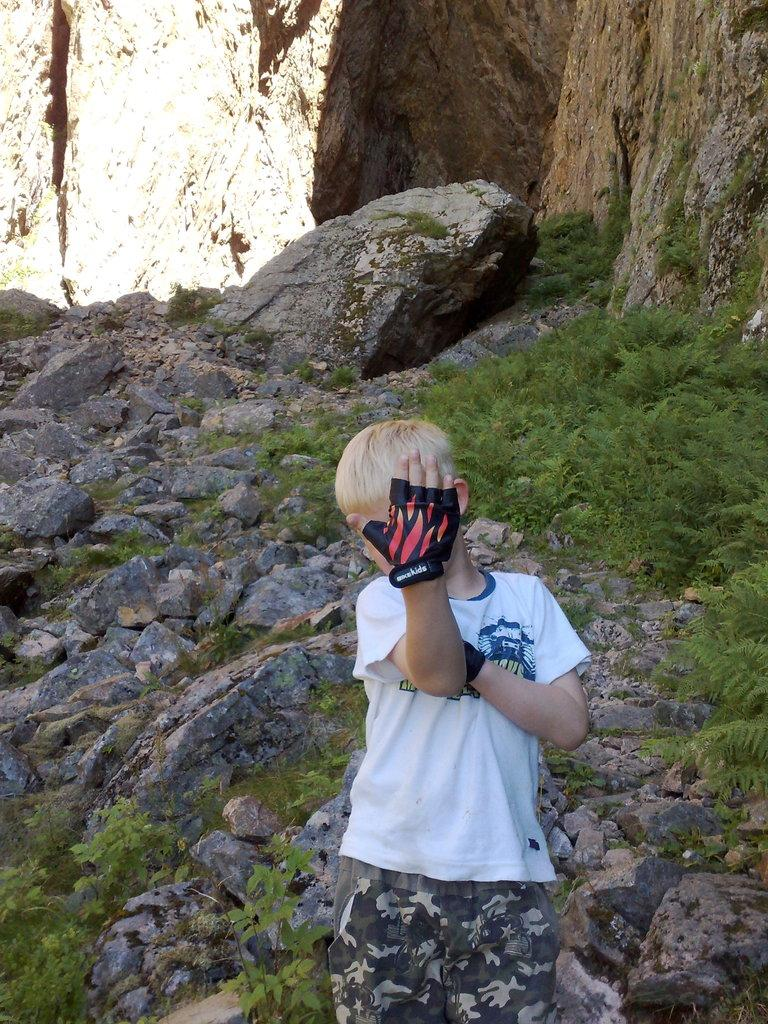What is the main subject of the image? The main subject of the image is a kid standing. What is the kid wearing on their hands? The kid is wearing gloves. What type of natural environment is visible in the background of the image? There are stones and grass visible in the background of the image. What type of road can be seen in the image? There is no road visible in the image; it features a kid standing with stones and grass in the background. 